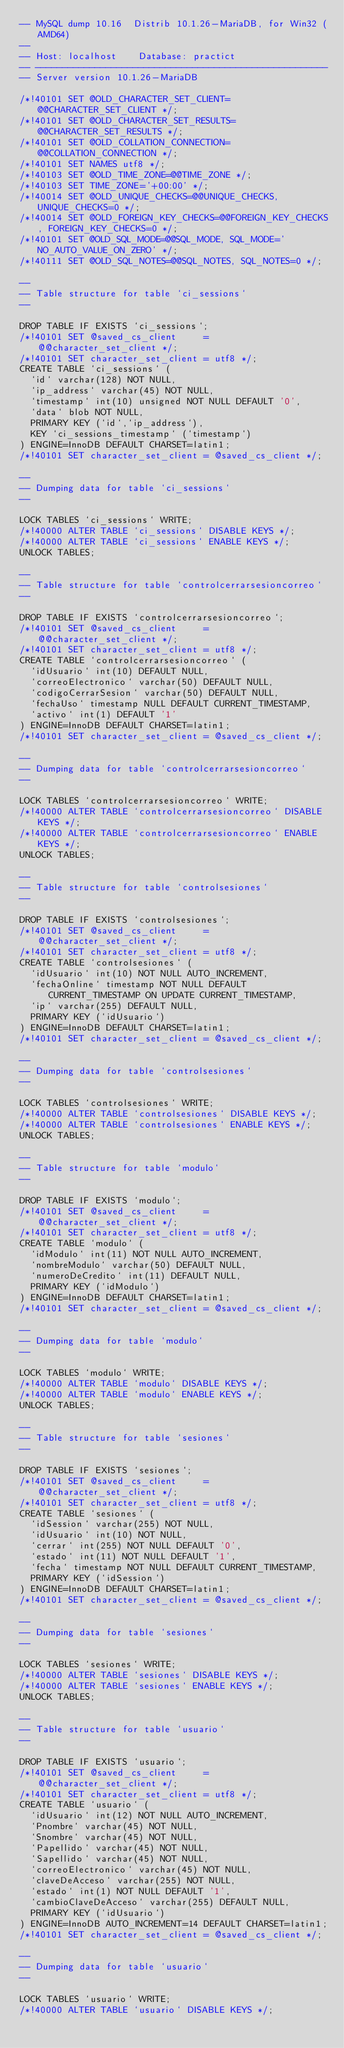Convert code to text. <code><loc_0><loc_0><loc_500><loc_500><_SQL_>-- MySQL dump 10.16  Distrib 10.1.26-MariaDB, for Win32 (AMD64)
--
-- Host: localhost    Database: practict
-- ------------------------------------------------------
-- Server version	10.1.26-MariaDB

/*!40101 SET @OLD_CHARACTER_SET_CLIENT=@@CHARACTER_SET_CLIENT */;
/*!40101 SET @OLD_CHARACTER_SET_RESULTS=@@CHARACTER_SET_RESULTS */;
/*!40101 SET @OLD_COLLATION_CONNECTION=@@COLLATION_CONNECTION */;
/*!40101 SET NAMES utf8 */;
/*!40103 SET @OLD_TIME_ZONE=@@TIME_ZONE */;
/*!40103 SET TIME_ZONE='+00:00' */;
/*!40014 SET @OLD_UNIQUE_CHECKS=@@UNIQUE_CHECKS, UNIQUE_CHECKS=0 */;
/*!40014 SET @OLD_FOREIGN_KEY_CHECKS=@@FOREIGN_KEY_CHECKS, FOREIGN_KEY_CHECKS=0 */;
/*!40101 SET @OLD_SQL_MODE=@@SQL_MODE, SQL_MODE='NO_AUTO_VALUE_ON_ZERO' */;
/*!40111 SET @OLD_SQL_NOTES=@@SQL_NOTES, SQL_NOTES=0 */;

--
-- Table structure for table `ci_sessions`
--

DROP TABLE IF EXISTS `ci_sessions`;
/*!40101 SET @saved_cs_client     = @@character_set_client */;
/*!40101 SET character_set_client = utf8 */;
CREATE TABLE `ci_sessions` (
  `id` varchar(128) NOT NULL,
  `ip_address` varchar(45) NOT NULL,
  `timestamp` int(10) unsigned NOT NULL DEFAULT '0',
  `data` blob NOT NULL,
  PRIMARY KEY (`id`,`ip_address`),
  KEY `ci_sessions_timestamp` (`timestamp`)
) ENGINE=InnoDB DEFAULT CHARSET=latin1;
/*!40101 SET character_set_client = @saved_cs_client */;

--
-- Dumping data for table `ci_sessions`
--

LOCK TABLES `ci_sessions` WRITE;
/*!40000 ALTER TABLE `ci_sessions` DISABLE KEYS */;
/*!40000 ALTER TABLE `ci_sessions` ENABLE KEYS */;
UNLOCK TABLES;

--
-- Table structure for table `controlcerrarsesioncorreo`
--

DROP TABLE IF EXISTS `controlcerrarsesioncorreo`;
/*!40101 SET @saved_cs_client     = @@character_set_client */;
/*!40101 SET character_set_client = utf8 */;
CREATE TABLE `controlcerrarsesioncorreo` (
  `idUsuario` int(10) DEFAULT NULL,
  `correoElectronico` varchar(50) DEFAULT NULL,
  `codigoCerrarSesion` varchar(50) DEFAULT NULL,
  `fechaUso` timestamp NULL DEFAULT CURRENT_TIMESTAMP,
  `activo` int(1) DEFAULT '1'
) ENGINE=InnoDB DEFAULT CHARSET=latin1;
/*!40101 SET character_set_client = @saved_cs_client */;

--
-- Dumping data for table `controlcerrarsesioncorreo`
--

LOCK TABLES `controlcerrarsesioncorreo` WRITE;
/*!40000 ALTER TABLE `controlcerrarsesioncorreo` DISABLE KEYS */;
/*!40000 ALTER TABLE `controlcerrarsesioncorreo` ENABLE KEYS */;
UNLOCK TABLES;

--
-- Table structure for table `controlsesiones`
--

DROP TABLE IF EXISTS `controlsesiones`;
/*!40101 SET @saved_cs_client     = @@character_set_client */;
/*!40101 SET character_set_client = utf8 */;
CREATE TABLE `controlsesiones` (
  `idUsuario` int(10) NOT NULL AUTO_INCREMENT,
  `fechaOnline` timestamp NOT NULL DEFAULT CURRENT_TIMESTAMP ON UPDATE CURRENT_TIMESTAMP,
  `ip` varchar(255) DEFAULT NULL,
  PRIMARY KEY (`idUsuario`)
) ENGINE=InnoDB DEFAULT CHARSET=latin1;
/*!40101 SET character_set_client = @saved_cs_client */;

--
-- Dumping data for table `controlsesiones`
--

LOCK TABLES `controlsesiones` WRITE;
/*!40000 ALTER TABLE `controlsesiones` DISABLE KEYS */;
/*!40000 ALTER TABLE `controlsesiones` ENABLE KEYS */;
UNLOCK TABLES;

--
-- Table structure for table `modulo`
--

DROP TABLE IF EXISTS `modulo`;
/*!40101 SET @saved_cs_client     = @@character_set_client */;
/*!40101 SET character_set_client = utf8 */;
CREATE TABLE `modulo` (
  `idModulo` int(11) NOT NULL AUTO_INCREMENT,
  `nombreModulo` varchar(50) DEFAULT NULL,
  `numeroDeCredito` int(11) DEFAULT NULL,
  PRIMARY KEY (`idModulo`)
) ENGINE=InnoDB DEFAULT CHARSET=latin1;
/*!40101 SET character_set_client = @saved_cs_client */;

--
-- Dumping data for table `modulo`
--

LOCK TABLES `modulo` WRITE;
/*!40000 ALTER TABLE `modulo` DISABLE KEYS */;
/*!40000 ALTER TABLE `modulo` ENABLE KEYS */;
UNLOCK TABLES;

--
-- Table structure for table `sesiones`
--

DROP TABLE IF EXISTS `sesiones`;
/*!40101 SET @saved_cs_client     = @@character_set_client */;
/*!40101 SET character_set_client = utf8 */;
CREATE TABLE `sesiones` (
  `idSession` varchar(255) NOT NULL,
  `idUsuario` int(10) NOT NULL,
  `cerrar` int(255) NOT NULL DEFAULT '0',
  `estado` int(11) NOT NULL DEFAULT '1',
  `fecha` timestamp NOT NULL DEFAULT CURRENT_TIMESTAMP,
  PRIMARY KEY (`idSession`)
) ENGINE=InnoDB DEFAULT CHARSET=latin1;
/*!40101 SET character_set_client = @saved_cs_client */;

--
-- Dumping data for table `sesiones`
--

LOCK TABLES `sesiones` WRITE;
/*!40000 ALTER TABLE `sesiones` DISABLE KEYS */;
/*!40000 ALTER TABLE `sesiones` ENABLE KEYS */;
UNLOCK TABLES;

--
-- Table structure for table `usuario`
--

DROP TABLE IF EXISTS `usuario`;
/*!40101 SET @saved_cs_client     = @@character_set_client */;
/*!40101 SET character_set_client = utf8 */;
CREATE TABLE `usuario` (
  `idUsuario` int(12) NOT NULL AUTO_INCREMENT,
  `Pnombre` varchar(45) NOT NULL,
  `Snombre` varchar(45) NOT NULL,
  `Papellido` varchar(45) NOT NULL,
  `Sapellido` varchar(45) NOT NULL,
  `correoElectronico` varchar(45) NOT NULL,
  `claveDeAcceso` varchar(255) NOT NULL,
  `estado` int(1) NOT NULL DEFAULT '1',
  `cambioClaveDeAcceso` varchar(255) DEFAULT NULL,
  PRIMARY KEY (`idUsuario`)
) ENGINE=InnoDB AUTO_INCREMENT=14 DEFAULT CHARSET=latin1;
/*!40101 SET character_set_client = @saved_cs_client */;

--
-- Dumping data for table `usuario`
--

LOCK TABLES `usuario` WRITE;
/*!40000 ALTER TABLE `usuario` DISABLE KEYS */;</code> 